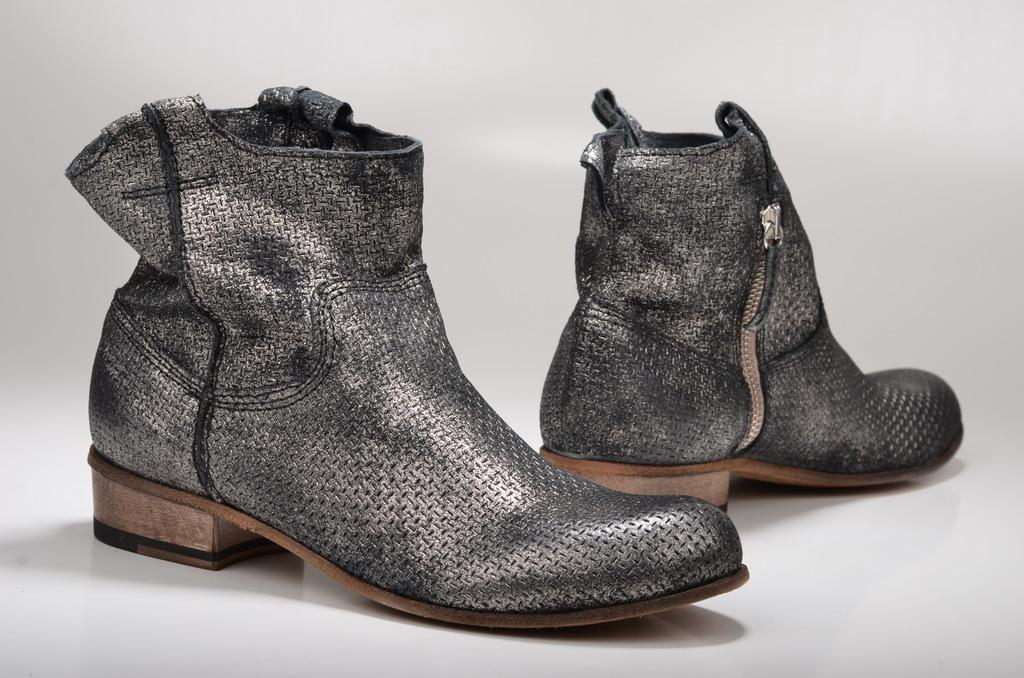What type of footwear is present in the image? There is a pair of shoes in the image. What can be seen beneath the shoes in the image? The ground is visible in the image. What type of gold meat is being prepared on the ground in the image? There is no gold meat or any meat preparation visible in the image; it only features a pair of shoes and the ground. 